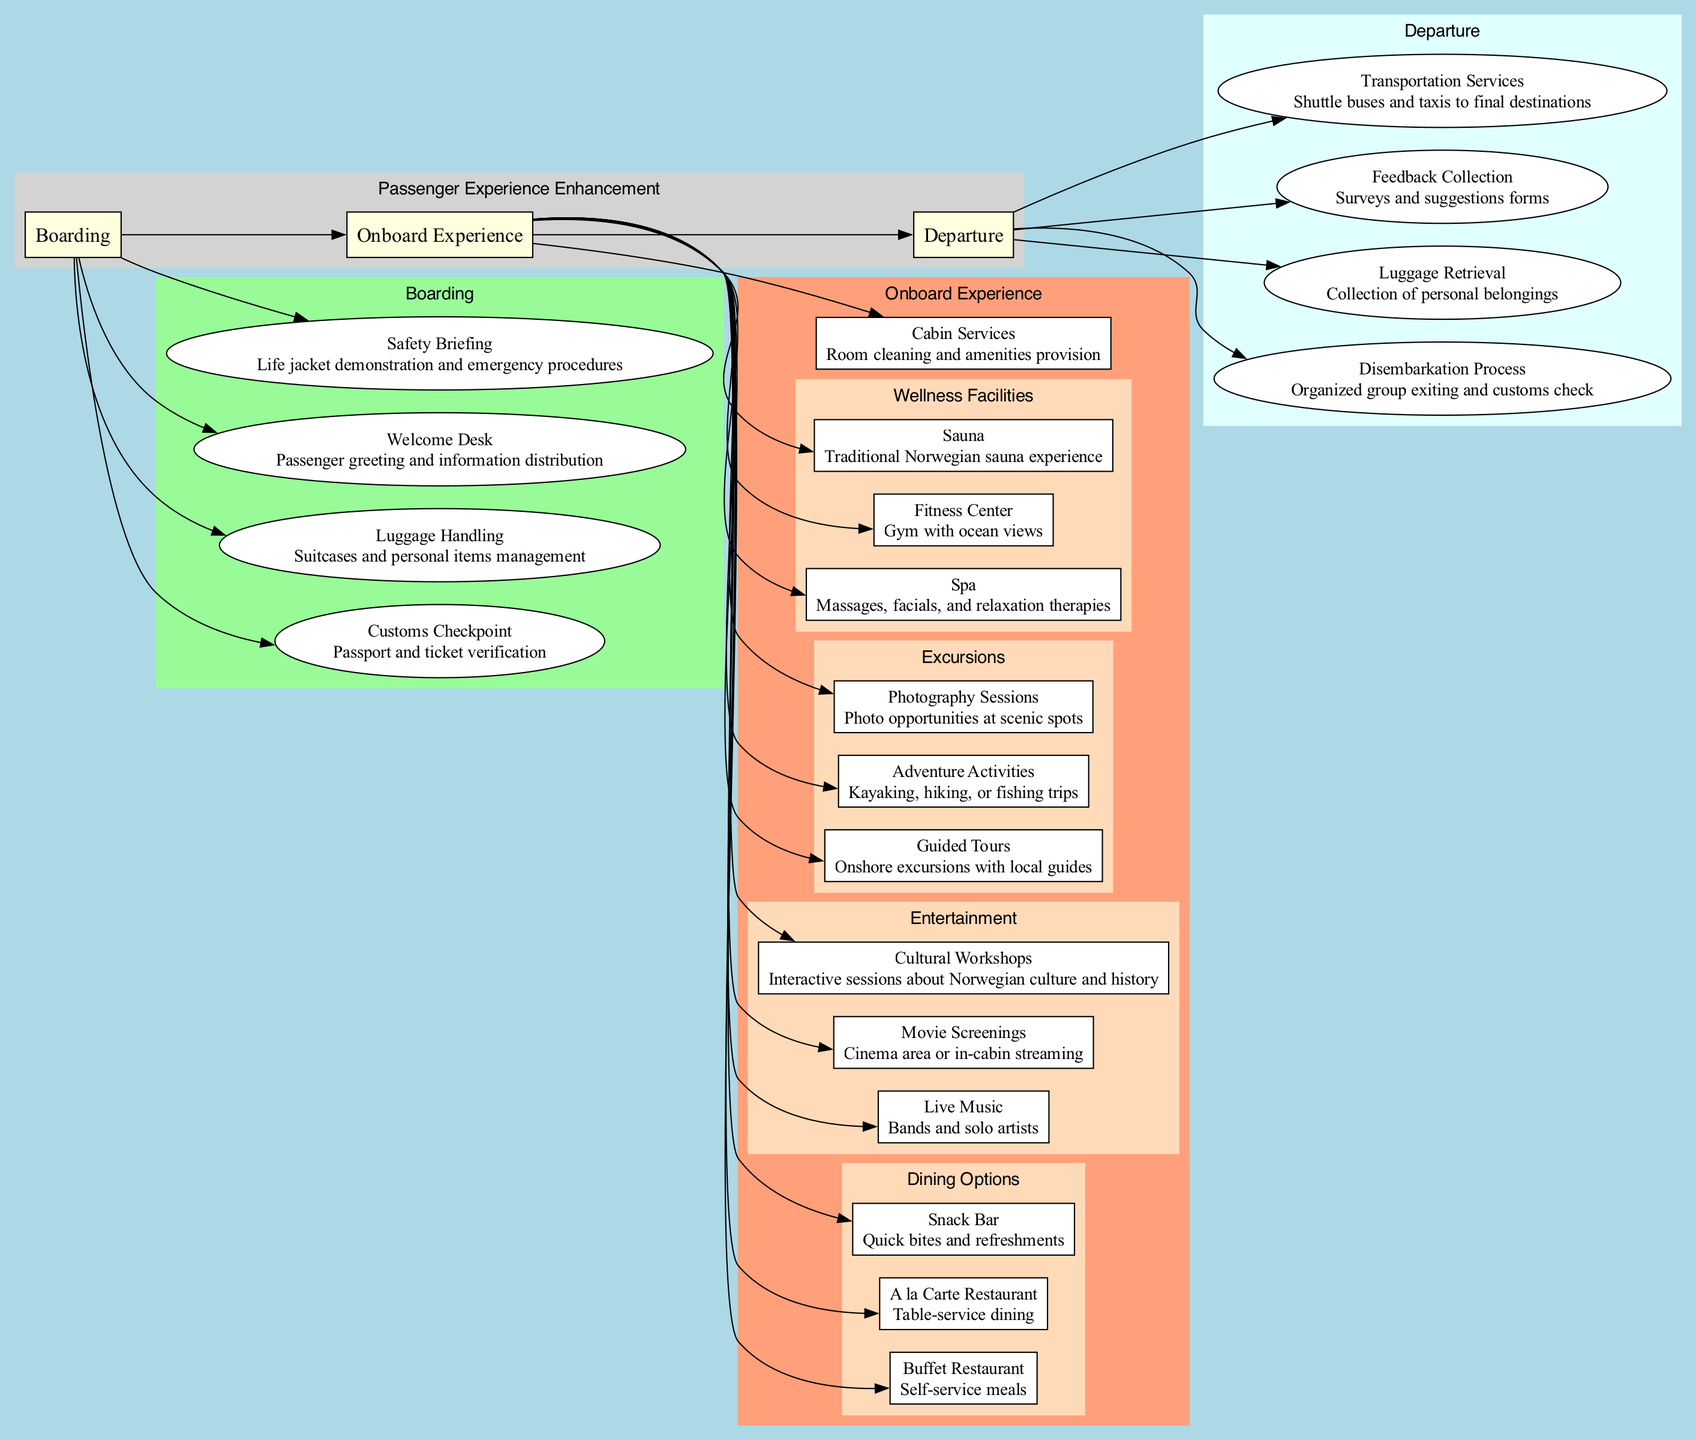What are the main sections of the diagram? The diagram has three main sections: Boarding, Onboard Experience, and Departure. Each section represents a phase in the passenger journey and contains various touchpoints within them.
Answer: Boarding, Onboard Experience, Departure How many touchpoints are listed under Boarding? Under the Boarding section, there are four touchpoints listed: Customs Checkpoint, Luggage Handling, Welcome Desk, and Safety Briefing.
Answer: 4 What type of dining options are available onboard? The onboard experience includes three types of dining options: Buffet Restaurant, A la Carte Restaurant, and Snack Bar. This can be deduced by examining the various services listed under the Onboard Experience category.
Answer: Buffet Restaurant, A la Carte Restaurant, Snack Bar Which service provides entertainment onboard? Entertainment services are provided through Live Music, Movie Screenings, and Cultural Workshops, as shown under the Onboard Experience section. This indicates various forms of leisure activities available for passengers.
Answer: Live Music, Movie Screenings, Cultural Workshops What is the first process after disembarking? The first process after disembarking passengers is the Disembarkation Process, which involves organized group exiting and customs check. This reflects the sequential flow of activities listed under the Departure section.
Answer: Disembarkation Process How are excursions categorized in the diagram? Excursions are categorized into Guided Tours, Adventure Activities, and Photography Sessions within the Onboard Experience section. This categorization shows the different types of experiences offered to passengers during their journey.
Answer: Guided Tours, Adventure Activities, Photography Sessions What type of feedback is collected during the departure? During departure, Feedback Collection involves surveys and suggestions forms, allowing passengers to contribute their opinions on the experience. This detail is specified under the Departure section of the diagram.
Answer: Surveys and suggestions forms How many categories are included in the Onboard Experience section? The Onboard Experience section includes five main categories: Cabin Services, Dining Options, Entertainment, Excursions, and Wellness Facilities. This total can be identified by counting the distinct groups within that section.
Answer: 5 